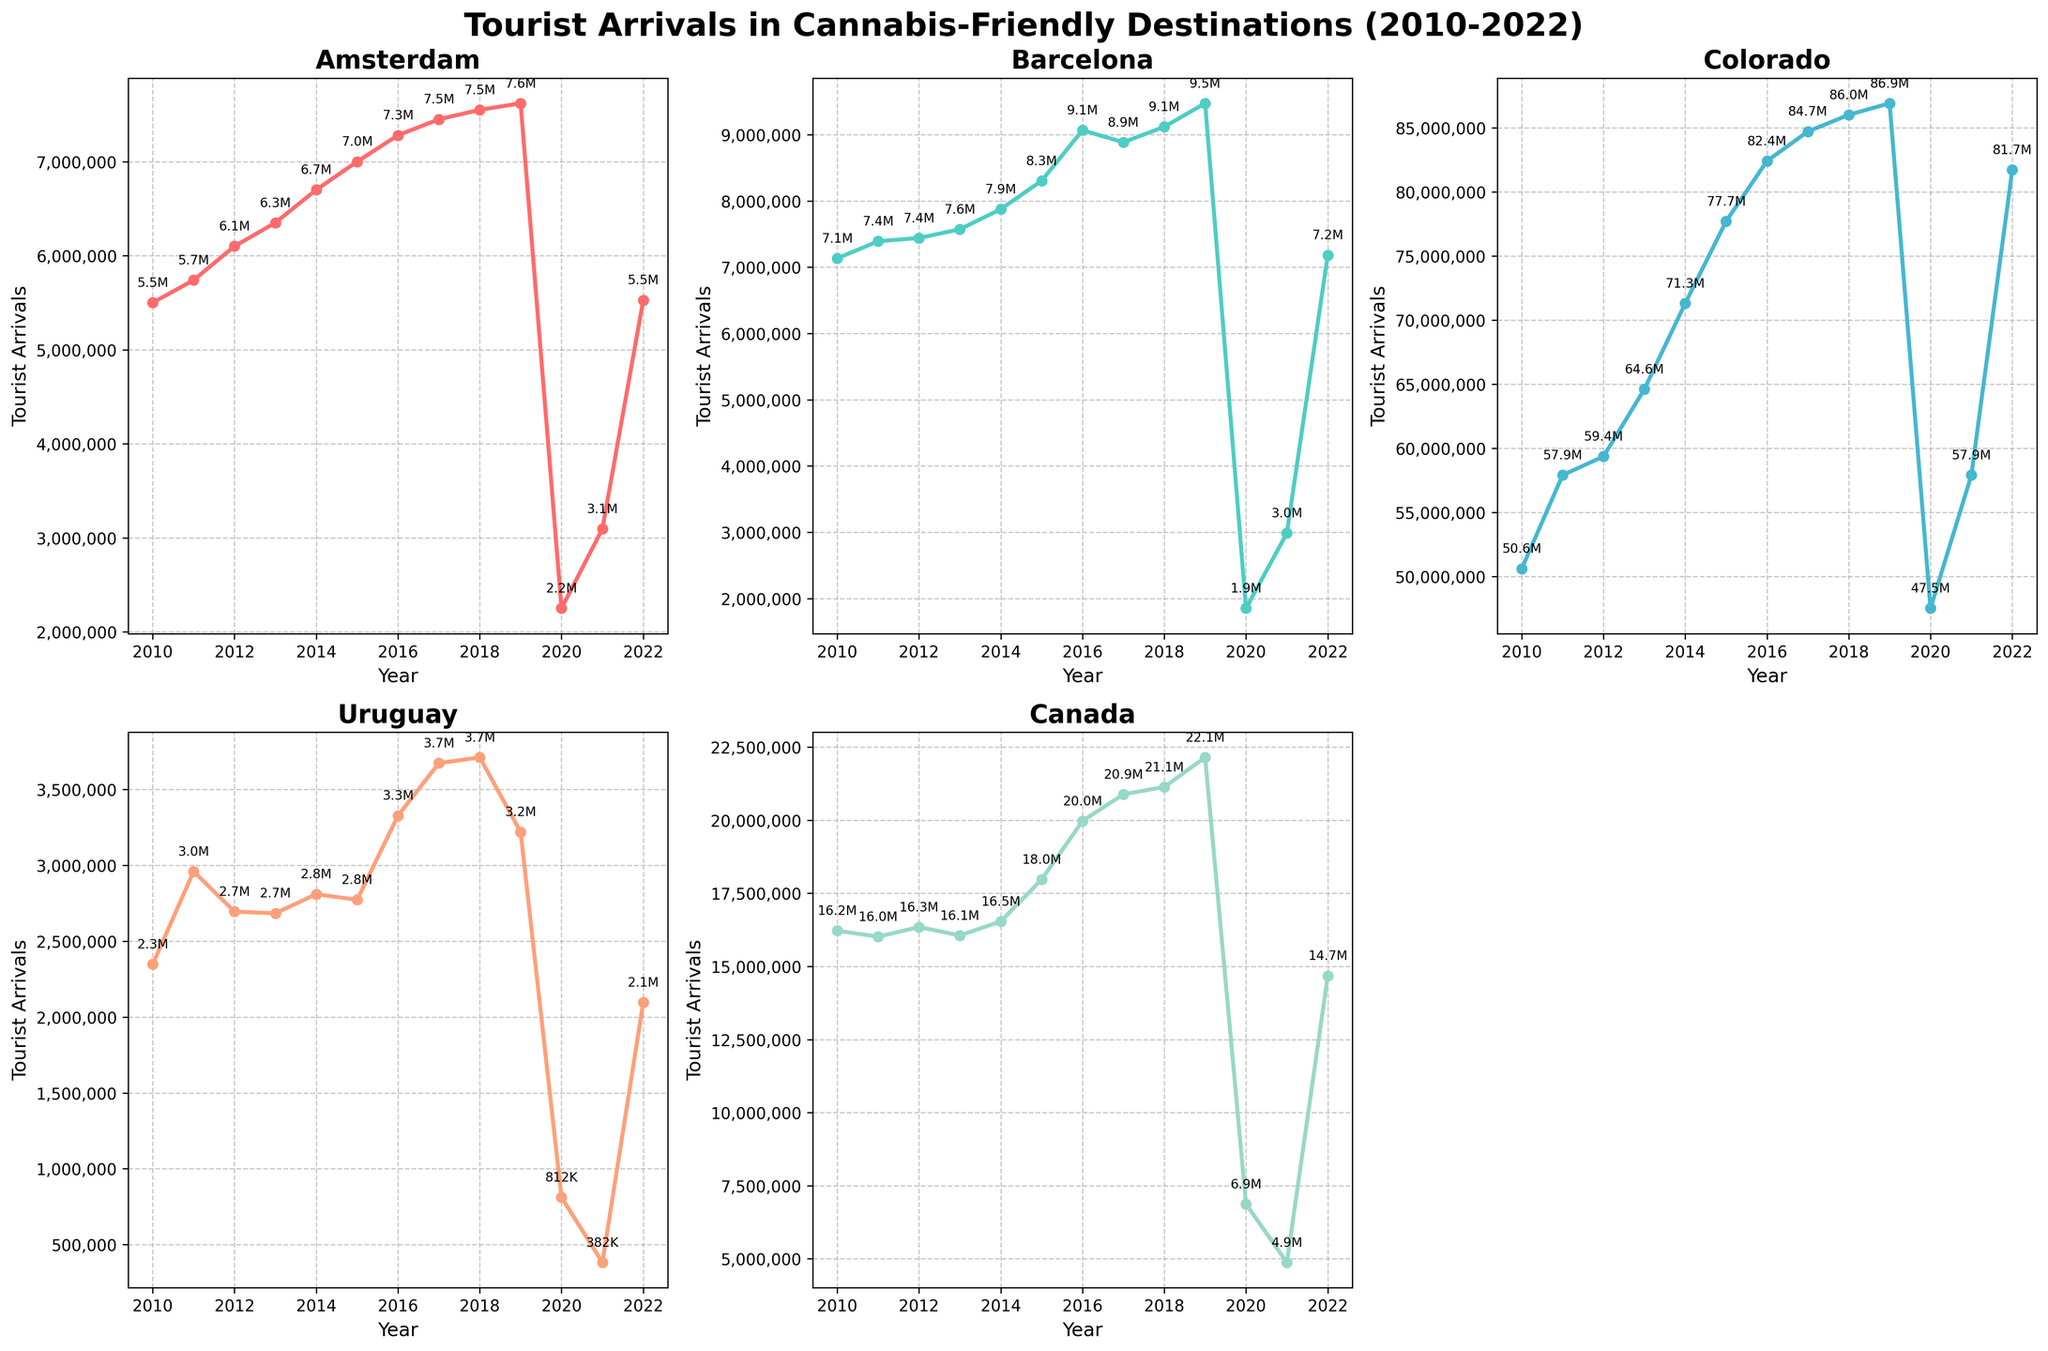When did Amsterdam experience the lowest number of tourist arrivals? The Amsterdam subplot shows a visible dip in 2020. The tourist arrivals in 2020 were at their lowest point compared to other years. By looking specifically at the data points, 2020 had 2,250,000 arrivals, which is the lowest observed.
Answer: 2020 Which year did Barcelona see a significant drop in tourist arrivals, following a peak year? From the Barcelona subplot, the peak in tourist arrivals occurred in 2019 with approximately 9,472,562 arrivals. A significant decline can be seen in the following year in 2020, where it dropped to about 1,852,491. The largest drop occurred from 2019 to 2020.
Answer: 2020 What's the average number of tourist arrivals in Canada from 2010 to 2022? To find the average, sum all the annual tourist arrival numbers in Canada from 2010 to 2022 and then divide that total by the number of years (13 years). Summing up the values: 16219320 + 16015534 + 16344402 + 16059180 + 16537235 + 17970304 + 19971249 + 20883962 + 21134273 + 22145275 + 6873485 + 4874897 + 14678077 gives 2.34e+08. Dividing this by 13 gives approximately 1.8e+07.
Answer: Approx. 18 million Comparing Amsterdam and Colorado, which one had more tourist arrivals in 2015? Referring to the subplots, we see Amsterdam had 7,000,000 tourist arrivals in 2015, while Colorado had 77,700,000 in the same year. Colorado had significantly more tourists than Amsterdam in 2015.
Answer: Colorado How did the number of tourist arrivals in Uruguay change between 2019 and 2022? Checking Uruguay’s subplot, the tourist arrivals in 2019 were 3,220,352 and in 2022 were 2,097,671. The change is calculated as 2,097,671 - 3,220,352 = -1,122,681. This shows a decrease of 1,122,681 tourist arrivals.
Answer: Decreased by 1,122,681 What is the trend observed in tourist arrivals in Colorado from 2010 to 2022? Examining the Colorado subplot, tourist arrivals generally increase from 2010 to 2019, although a dip is seen in 2020, probably due to the pandemic, before they rise again through 2022. The overall trend is an upward trajectory.
Answer: Upward trend By how much did the tourist arrivals in Amsterdam drop from 2019 to 2020? The subplot for Amsterdam shows that tourist numbers dropped from 7,620,000 in 2019 to 2,250,000 in 2020. The decrease can be calculated as 7,620,000 - 2,250,000 = 5,370,000.
Answer: 5,370,000 Which destination was most affected in terms of tourist arrivals in 2020? Reviewing all the subplots, each destination shows a drop in 2020, but Barcelona and Colorado see the most significant drops. Barcelona dropped from 9,472,562 to 1,852,491 and Colorado from 86,900,000 to 47,508,192. The most notable difference is in Colorado, with a high fall in absolute numbers.
Answer: Colorado 